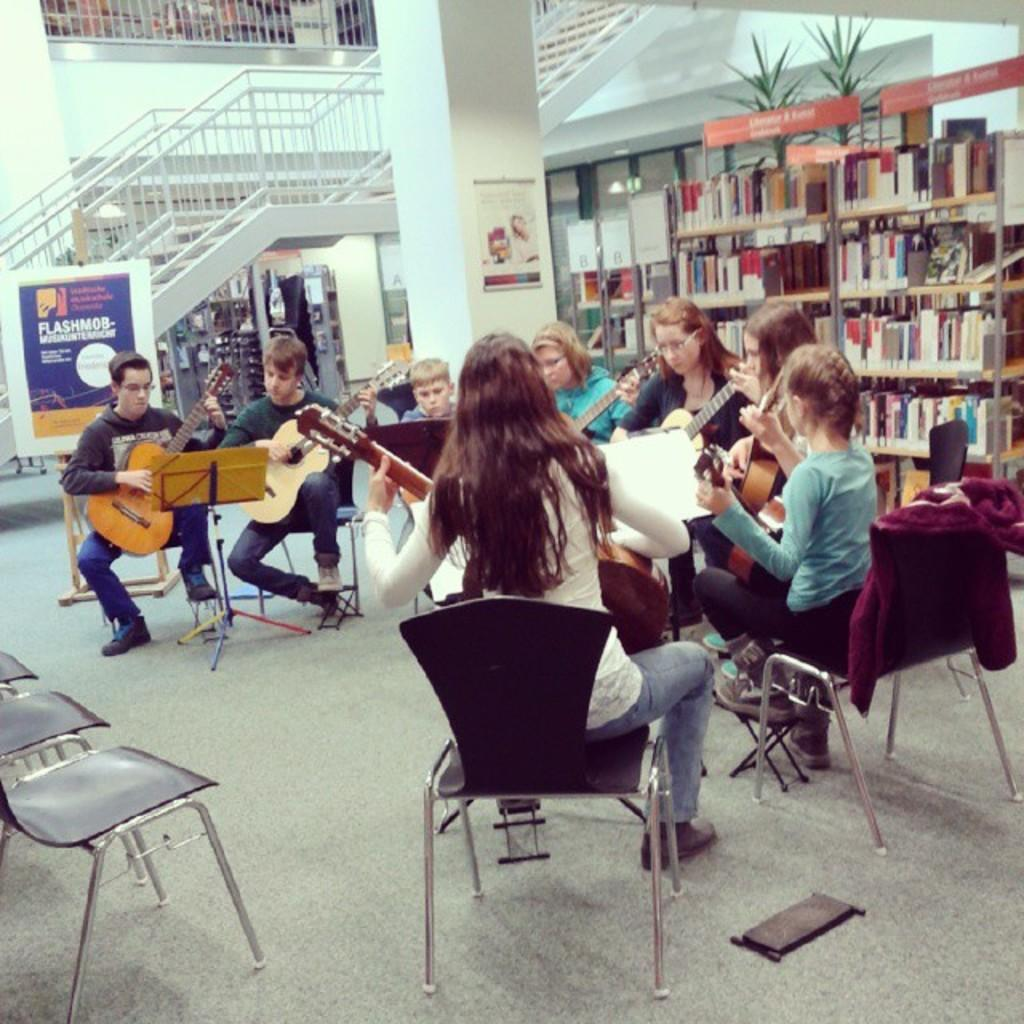How many people are in the image? There is a group of people in the image. What are the people doing in the image? The people are sitting on chairs and playing a guitar. What can be seen in the background of the image? There are bookshelves in the background of the image. What architectural feature is present in the image? There is a staircase in the image. What type of bread is being smashed by the wrist in the image? There is no bread or wrist present in the image. What type of wrist injury can be seen in the image? There is no wrist injury or any reference to a wrist in the image. 